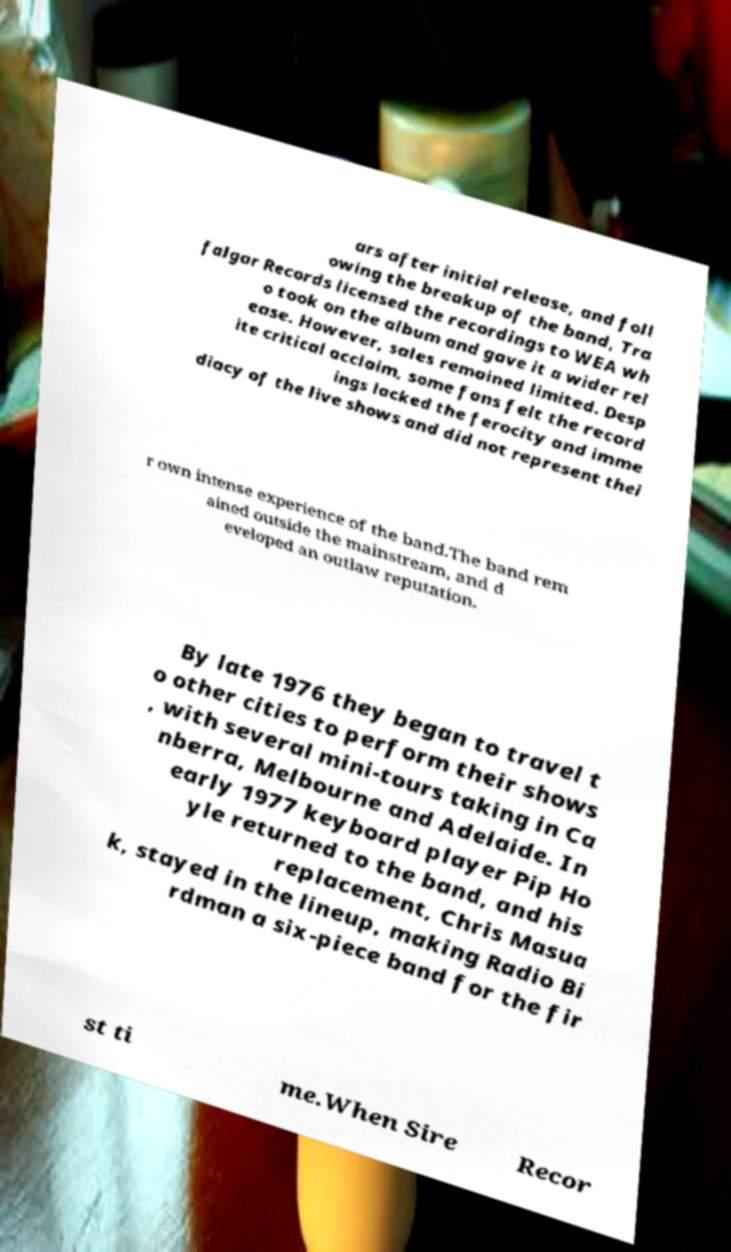There's text embedded in this image that I need extracted. Can you transcribe it verbatim? ars after initial release, and foll owing the breakup of the band, Tra falgar Records licensed the recordings to WEA wh o took on the album and gave it a wider rel ease. However, sales remained limited. Desp ite critical acclaim, some fans felt the record ings lacked the ferocity and imme diacy of the live shows and did not represent thei r own intense experience of the band.The band rem ained outside the mainstream, and d eveloped an outlaw reputation. By late 1976 they began to travel t o other cities to perform their shows , with several mini-tours taking in Ca nberra, Melbourne and Adelaide. In early 1977 keyboard player Pip Ho yle returned to the band, and his replacement, Chris Masua k, stayed in the lineup, making Radio Bi rdman a six-piece band for the fir st ti me.When Sire Recor 